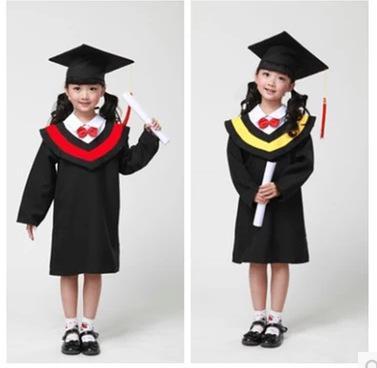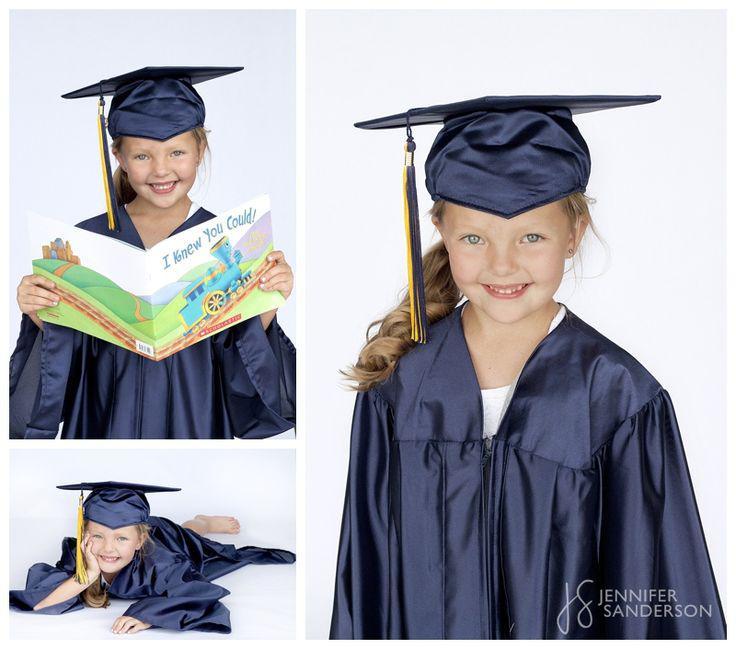The first image is the image on the left, the second image is the image on the right. For the images shown, is this caption "In one of the images there are a pair of students wearing a graduation cap and gown." true? Answer yes or no. Yes. 